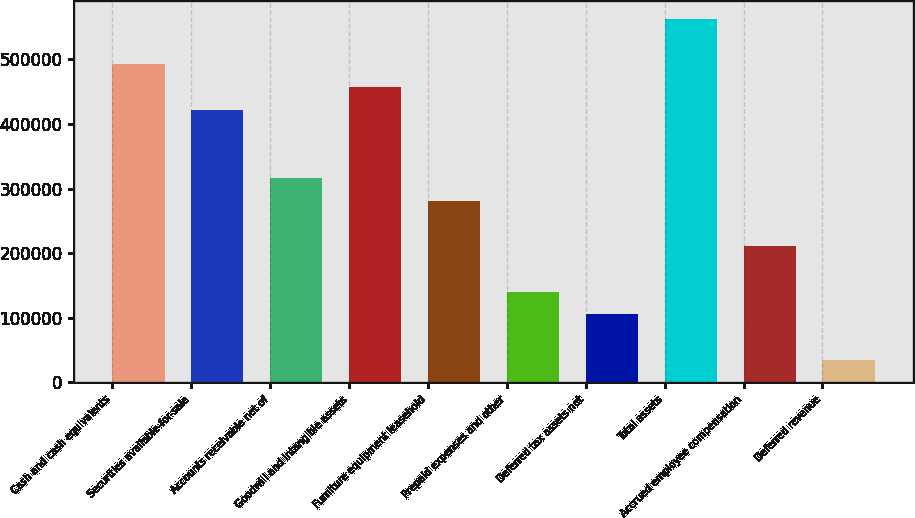<chart> <loc_0><loc_0><loc_500><loc_500><bar_chart><fcel>Cash and cash equivalents<fcel>Securities available-for-sale<fcel>Accounts receivable net of<fcel>Goodwill and intangible assets<fcel>Furniture equipment leasehold<fcel>Prepaid expenses and other<fcel>Deferred tax assets net<fcel>Total assets<fcel>Accrued employee compensation<fcel>Deferred revenue<nl><fcel>492162<fcel>421870<fcel>316432<fcel>457016<fcel>281286<fcel>140703<fcel>105557<fcel>562453<fcel>210994<fcel>35264.9<nl></chart> 